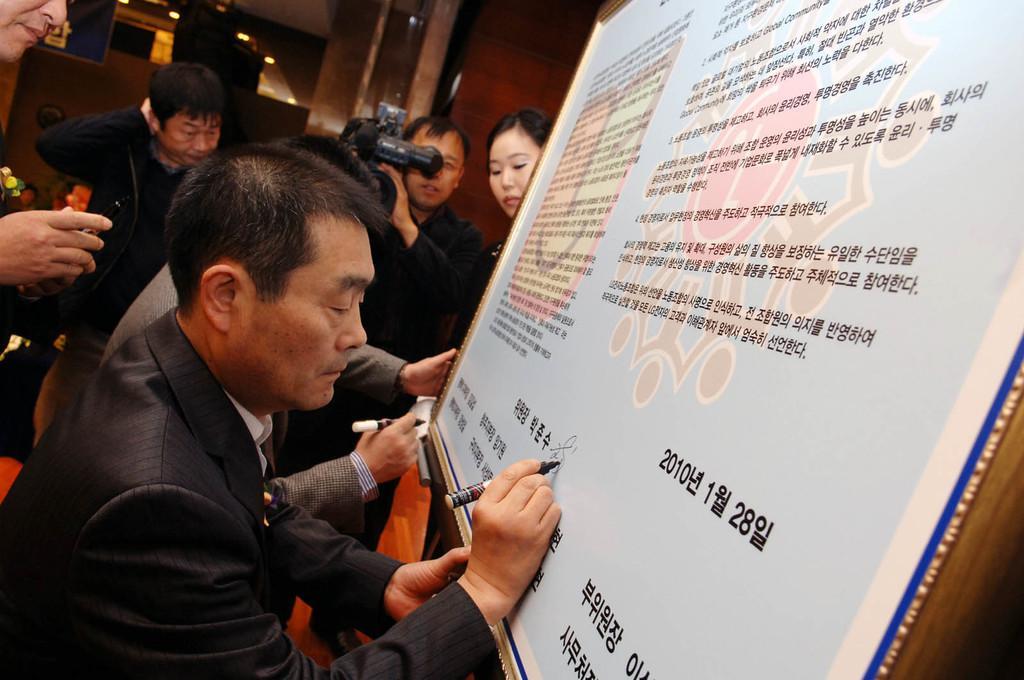Please provide a concise description of this image. In this image I can see the group of people with black and grey color dress. I can see few people holding the pens and one person holding the camera. In-front of these people I can see the board and text written on it. In the background I can see the lights. 